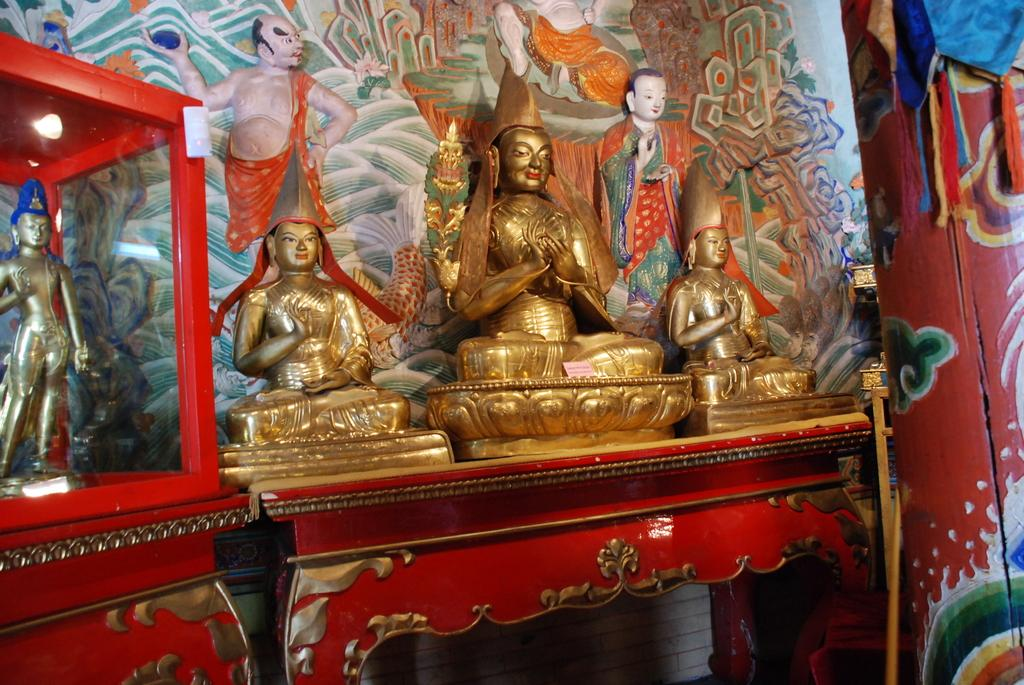What can be seen in the foreground of the image? There are statues in the foreground area of the image. Where are the statues located? The statues are on a desk. What is visible in the background of the image? There are paintings in the background of the image. Can you describe any other elements in the image? There appears to be a colorful curtain in the top right side of the image. How many cherries are on the pan in the image? There are no cherries or pans present in the image. 